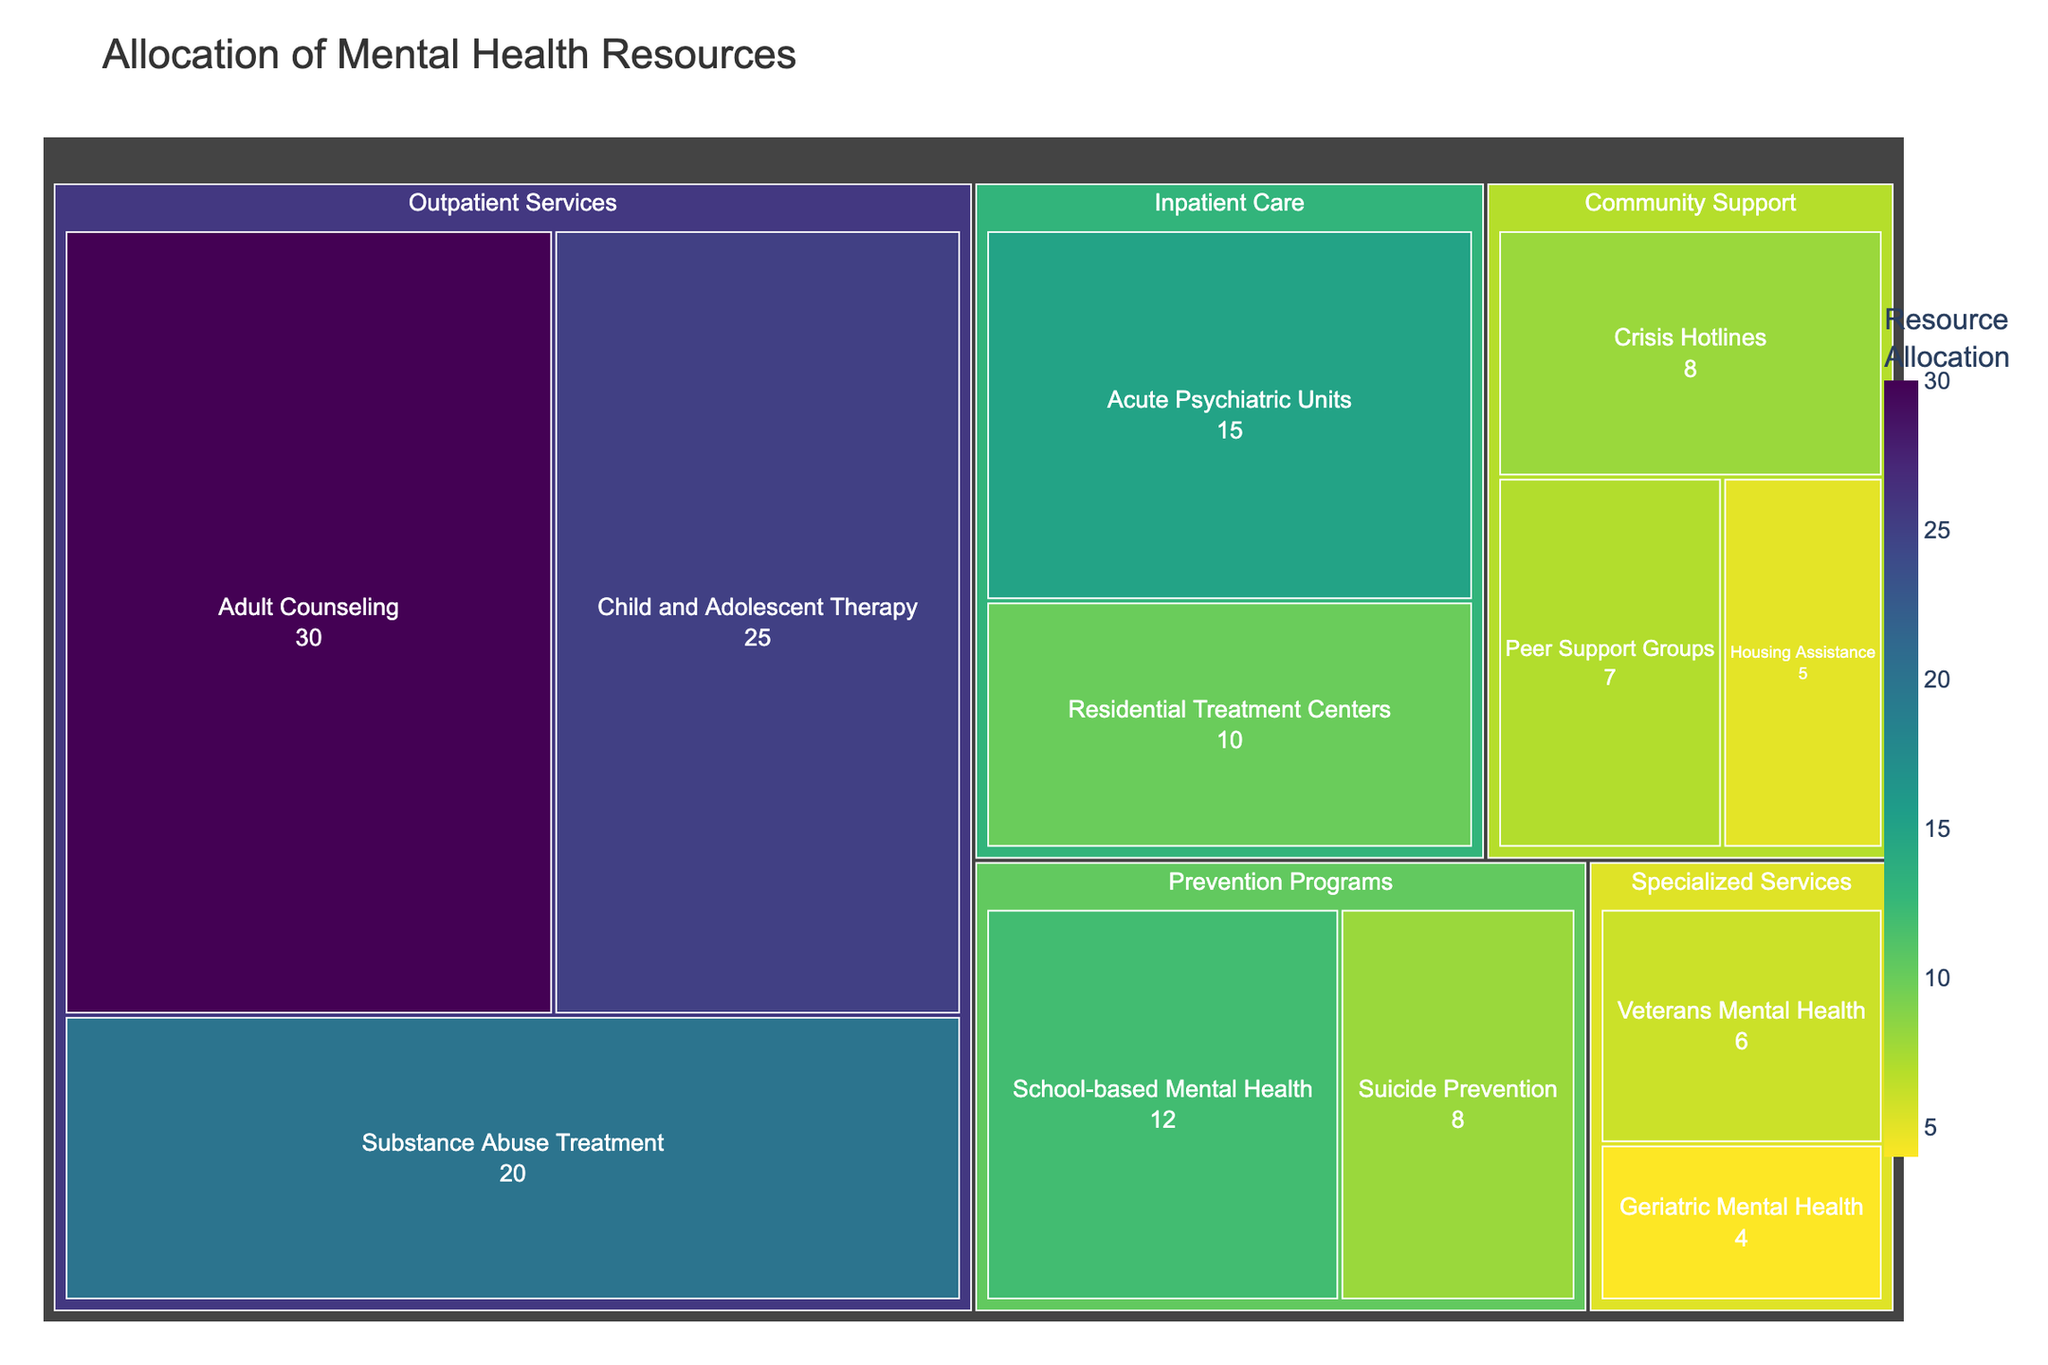What is the title of the figure? The title is displayed at the top of the treemap, and it reads "Allocation of Mental Health Resources."
Answer: Allocation of Mental Health Resources Which category has the highest resource allocation value? By looking at the largest segment in the treemap, we can see that "Outpatient Services" has the highest resource allocation.
Answer: Outpatient Services What is the total allocation value for Inpatient Care? Summing the values under "Inpatient Care" (Acute Psychiatric Units: 15, Residential Treatment Centers: 10) gives us 25.
Answer: 25 How does the allocation for Substance Abuse Treatment compare to that for Acute Psychiatric Units? Substance Abuse Treatment in Outpatient Services has a value of 20, while Acute Psychiatric Units in Inpatient Care has a value of 15. Thus, the former has a higher allocation.
Answer: Substance Abuse Treatment has a higher allocation What is the resource allocation for School-based Mental Health? The value for School-based Mental Health, found under Prevention Programs, is 12.
Answer: 12 Which subcategory in Community Support has the lowest allocation? Within Community Support, Housing Assistance has the lowest allocation with a value of 5.
Answer: Housing Assistance What is the difference in allocation between Child and Adolescent Therapy and Geriatric Mental Health? Child and Adolescent Therapy has an allocation of 25, while Geriatric Mental Health has 4. The difference is 25 - 4 = 21.
Answer: 21 How many categories have a subcategory with an allocation below 10? The categories with subcategories below 10 are Inpatient Care, Community Support, Prevention Programs, and Specialized Services, making a total of 4 categories.
Answer: 4 Which category has the more even distribution of resources among its subcategories, Outpatient Services or Community Support? Outpatient Services has a more even distribution (30, 25, 20) compared to Community Support (8, 7, 5), which has more variation.
Answer: Outpatient Services What is the combined allocation for all Specialized Services subcategories? Summing the values for Veterans Mental Health (6) and Geriatric Mental Health (4) gives 6 + 4 = 10.
Answer: 10 